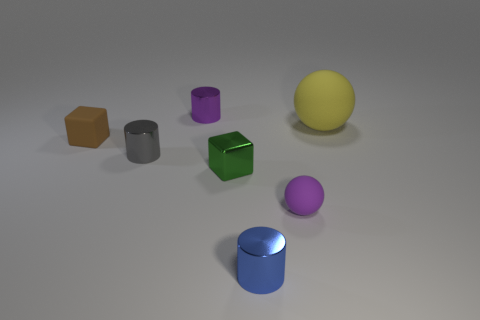Can you describe the colors and shapes of all the objects in the image? Certainly! In the image, there are six 3D objects with different colors and shapes. Starting from the left, there's a brown hexahedron (cube), a purple cylinder, a gray cylinder, a green hexahedron, a pink sphere, and a yellow sphere. 